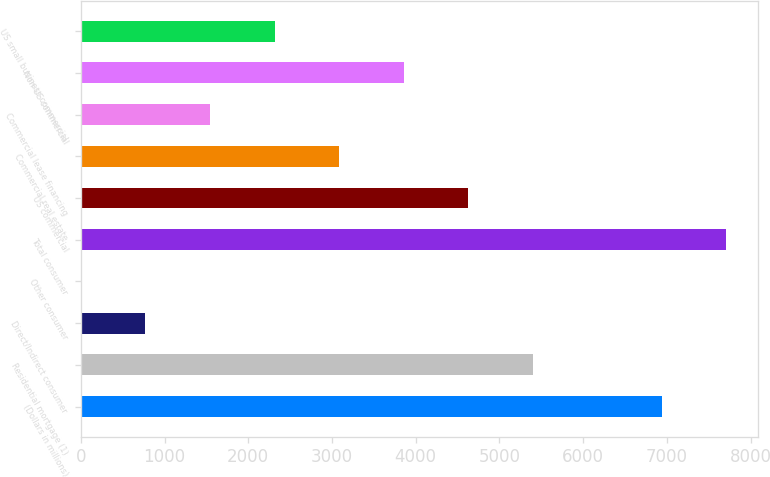Convert chart. <chart><loc_0><loc_0><loc_500><loc_500><bar_chart><fcel>(Dollars in millions)<fcel>Residential mortgage (1)<fcel>Direct/Indirect consumer<fcel>Other consumer<fcel>Total consumer<fcel>US commercial<fcel>Commercial real estate<fcel>Commercial lease financing<fcel>Non-US commercial<fcel>US small business commercial<nl><fcel>6936.5<fcel>5395.5<fcel>772.5<fcel>2<fcel>7707<fcel>4625<fcel>3084<fcel>1543<fcel>3854.5<fcel>2313.5<nl></chart> 